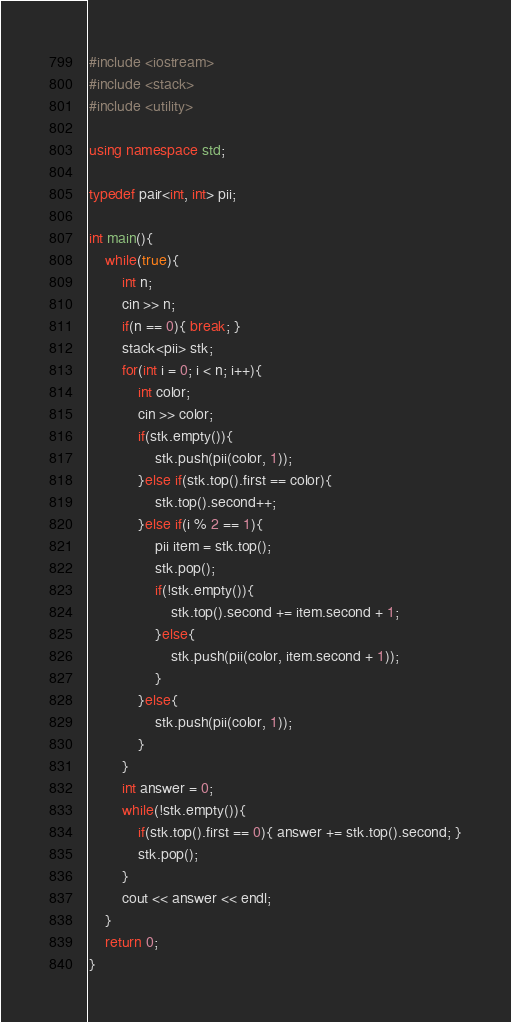Convert code to text. <code><loc_0><loc_0><loc_500><loc_500><_C++_>#include <iostream>
#include <stack>
#include <utility>

using namespace std;

typedef pair<int, int> pii;

int main(){
	while(true){
		int n;
		cin >> n;
		if(n == 0){ break; }
		stack<pii> stk;
		for(int i = 0; i < n; i++){
			int color;
			cin >> color;
			if(stk.empty()){
				stk.push(pii(color, 1));
			}else if(stk.top().first == color){
				stk.top().second++;
			}else if(i % 2 == 1){
				pii item = stk.top();
				stk.pop();
				if(!stk.empty()){
					stk.top().second += item.second + 1;
				}else{
					stk.push(pii(color, item.second + 1));
				}
			}else{
				stk.push(pii(color, 1));
			}
		}
		int answer = 0;
		while(!stk.empty()){
			if(stk.top().first == 0){ answer += stk.top().second; }
			stk.pop();
		}
		cout << answer << endl;
	}
	return 0;
}</code> 